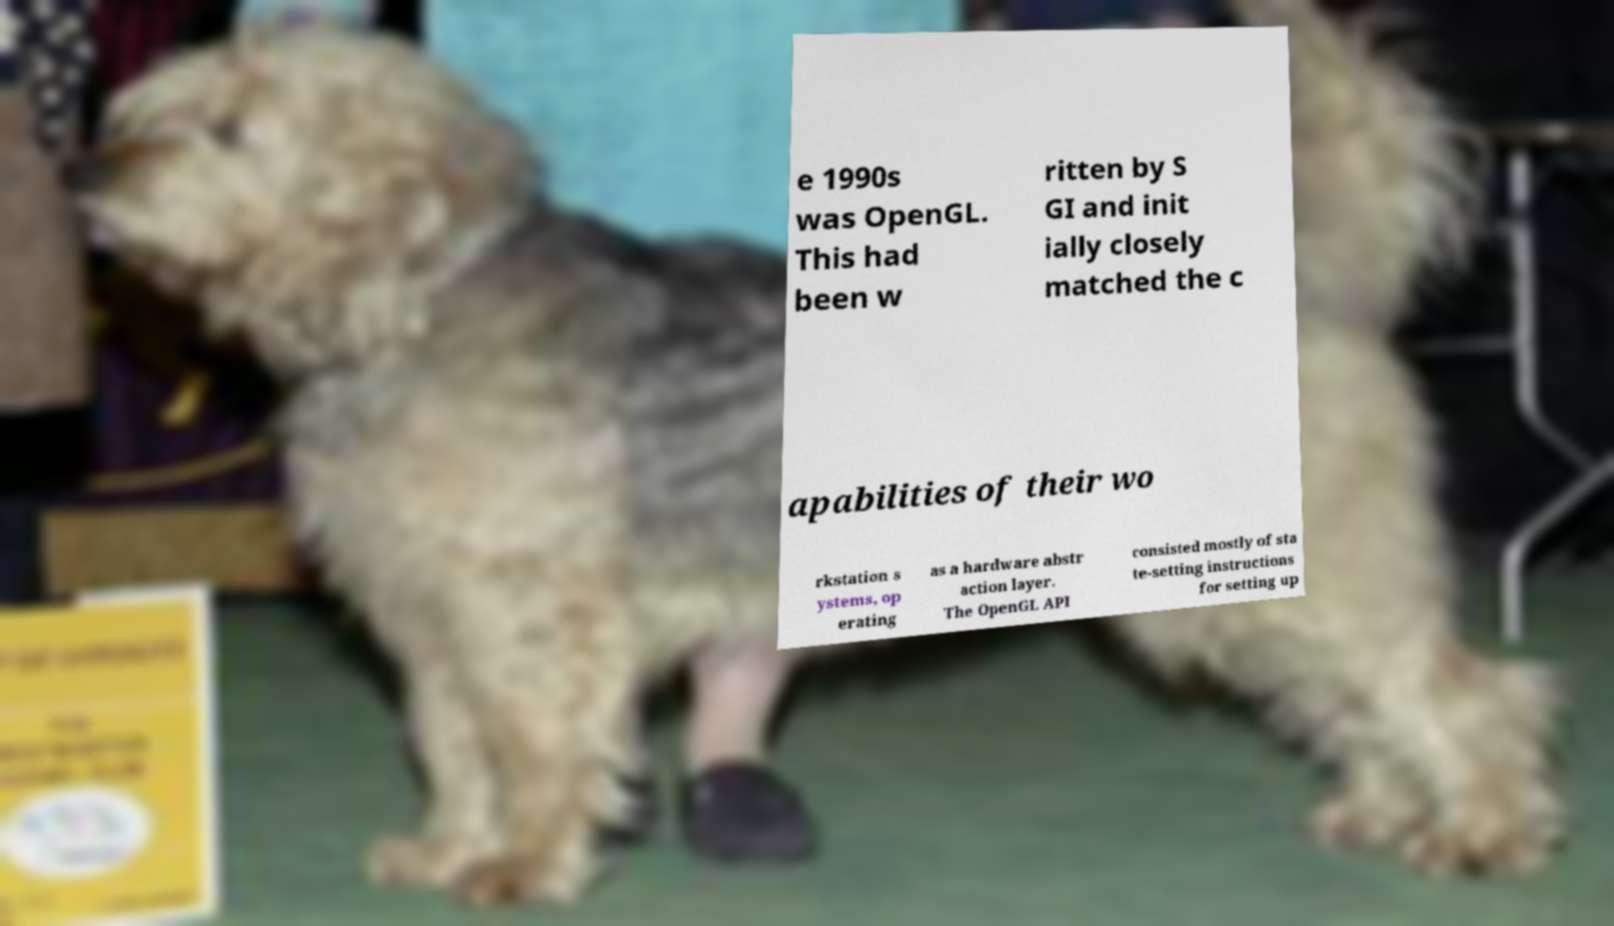Can you accurately transcribe the text from the provided image for me? e 1990s was OpenGL. This had been w ritten by S GI and init ially closely matched the c apabilities of their wo rkstation s ystems, op erating as a hardware abstr action layer. The OpenGL API consisted mostly of sta te-setting instructions for setting up 